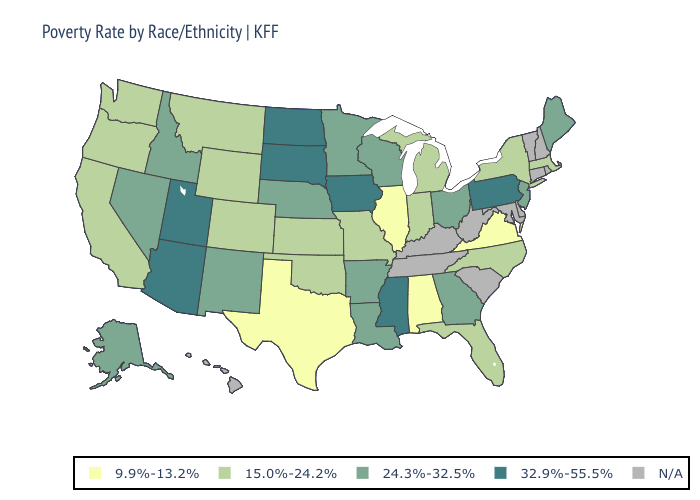What is the lowest value in the USA?
Quick response, please. 9.9%-13.2%. Which states hav the highest value in the South?
Be succinct. Mississippi. Name the states that have a value in the range 24.3%-32.5%?
Concise answer only. Alaska, Arkansas, Georgia, Idaho, Louisiana, Maine, Minnesota, Nebraska, Nevada, New Jersey, New Mexico, Ohio, Wisconsin. Which states have the lowest value in the USA?
Keep it brief. Alabama, Illinois, Texas, Virginia. Name the states that have a value in the range 32.9%-55.5%?
Be succinct. Arizona, Iowa, Mississippi, North Dakota, Pennsylvania, South Dakota, Utah. What is the value of Hawaii?
Answer briefly. N/A. Which states have the lowest value in the USA?
Short answer required. Alabama, Illinois, Texas, Virginia. What is the value of Oregon?
Be succinct. 15.0%-24.2%. Among the states that border Indiana , which have the highest value?
Short answer required. Ohio. Name the states that have a value in the range 32.9%-55.5%?
Short answer required. Arizona, Iowa, Mississippi, North Dakota, Pennsylvania, South Dakota, Utah. What is the value of Texas?
Quick response, please. 9.9%-13.2%. Does New Jersey have the lowest value in the Northeast?
Write a very short answer. No. Among the states that border New Jersey , does Pennsylvania have the highest value?
Give a very brief answer. Yes. Does Oregon have the lowest value in the West?
Short answer required. Yes. Among the states that border New Jersey , does New York have the lowest value?
Short answer required. Yes. 